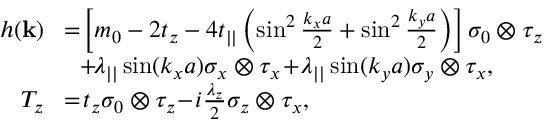<formula> <loc_0><loc_0><loc_500><loc_500>\begin{array} { r l } { h ( { k } ) } & { \, = \, \left [ m _ { 0 } - 2 t _ { z } - 4 t _ { | | } \left ( \sin ^ { 2 } \frac { k _ { x } a } { 2 } + \sin ^ { 2 } \frac { k _ { y } a } { 2 } \right ) \right ] \sigma _ { 0 } \otimes \tau _ { z } } \\ & { \, + \, \lambda _ { | | } \sin ( k _ { x } a ) \sigma _ { x } \otimes \tau _ { x } \, + \, \lambda _ { | | } \sin ( k _ { y } a ) \sigma _ { y } \otimes \tau _ { x } , } \\ { T _ { z } } & { \, = \, t _ { z } \sigma _ { 0 } \otimes \tau _ { z } \, - \, i \frac { \lambda _ { z } } { 2 } \sigma _ { z } \otimes \tau _ { x } , } \end{array}</formula> 